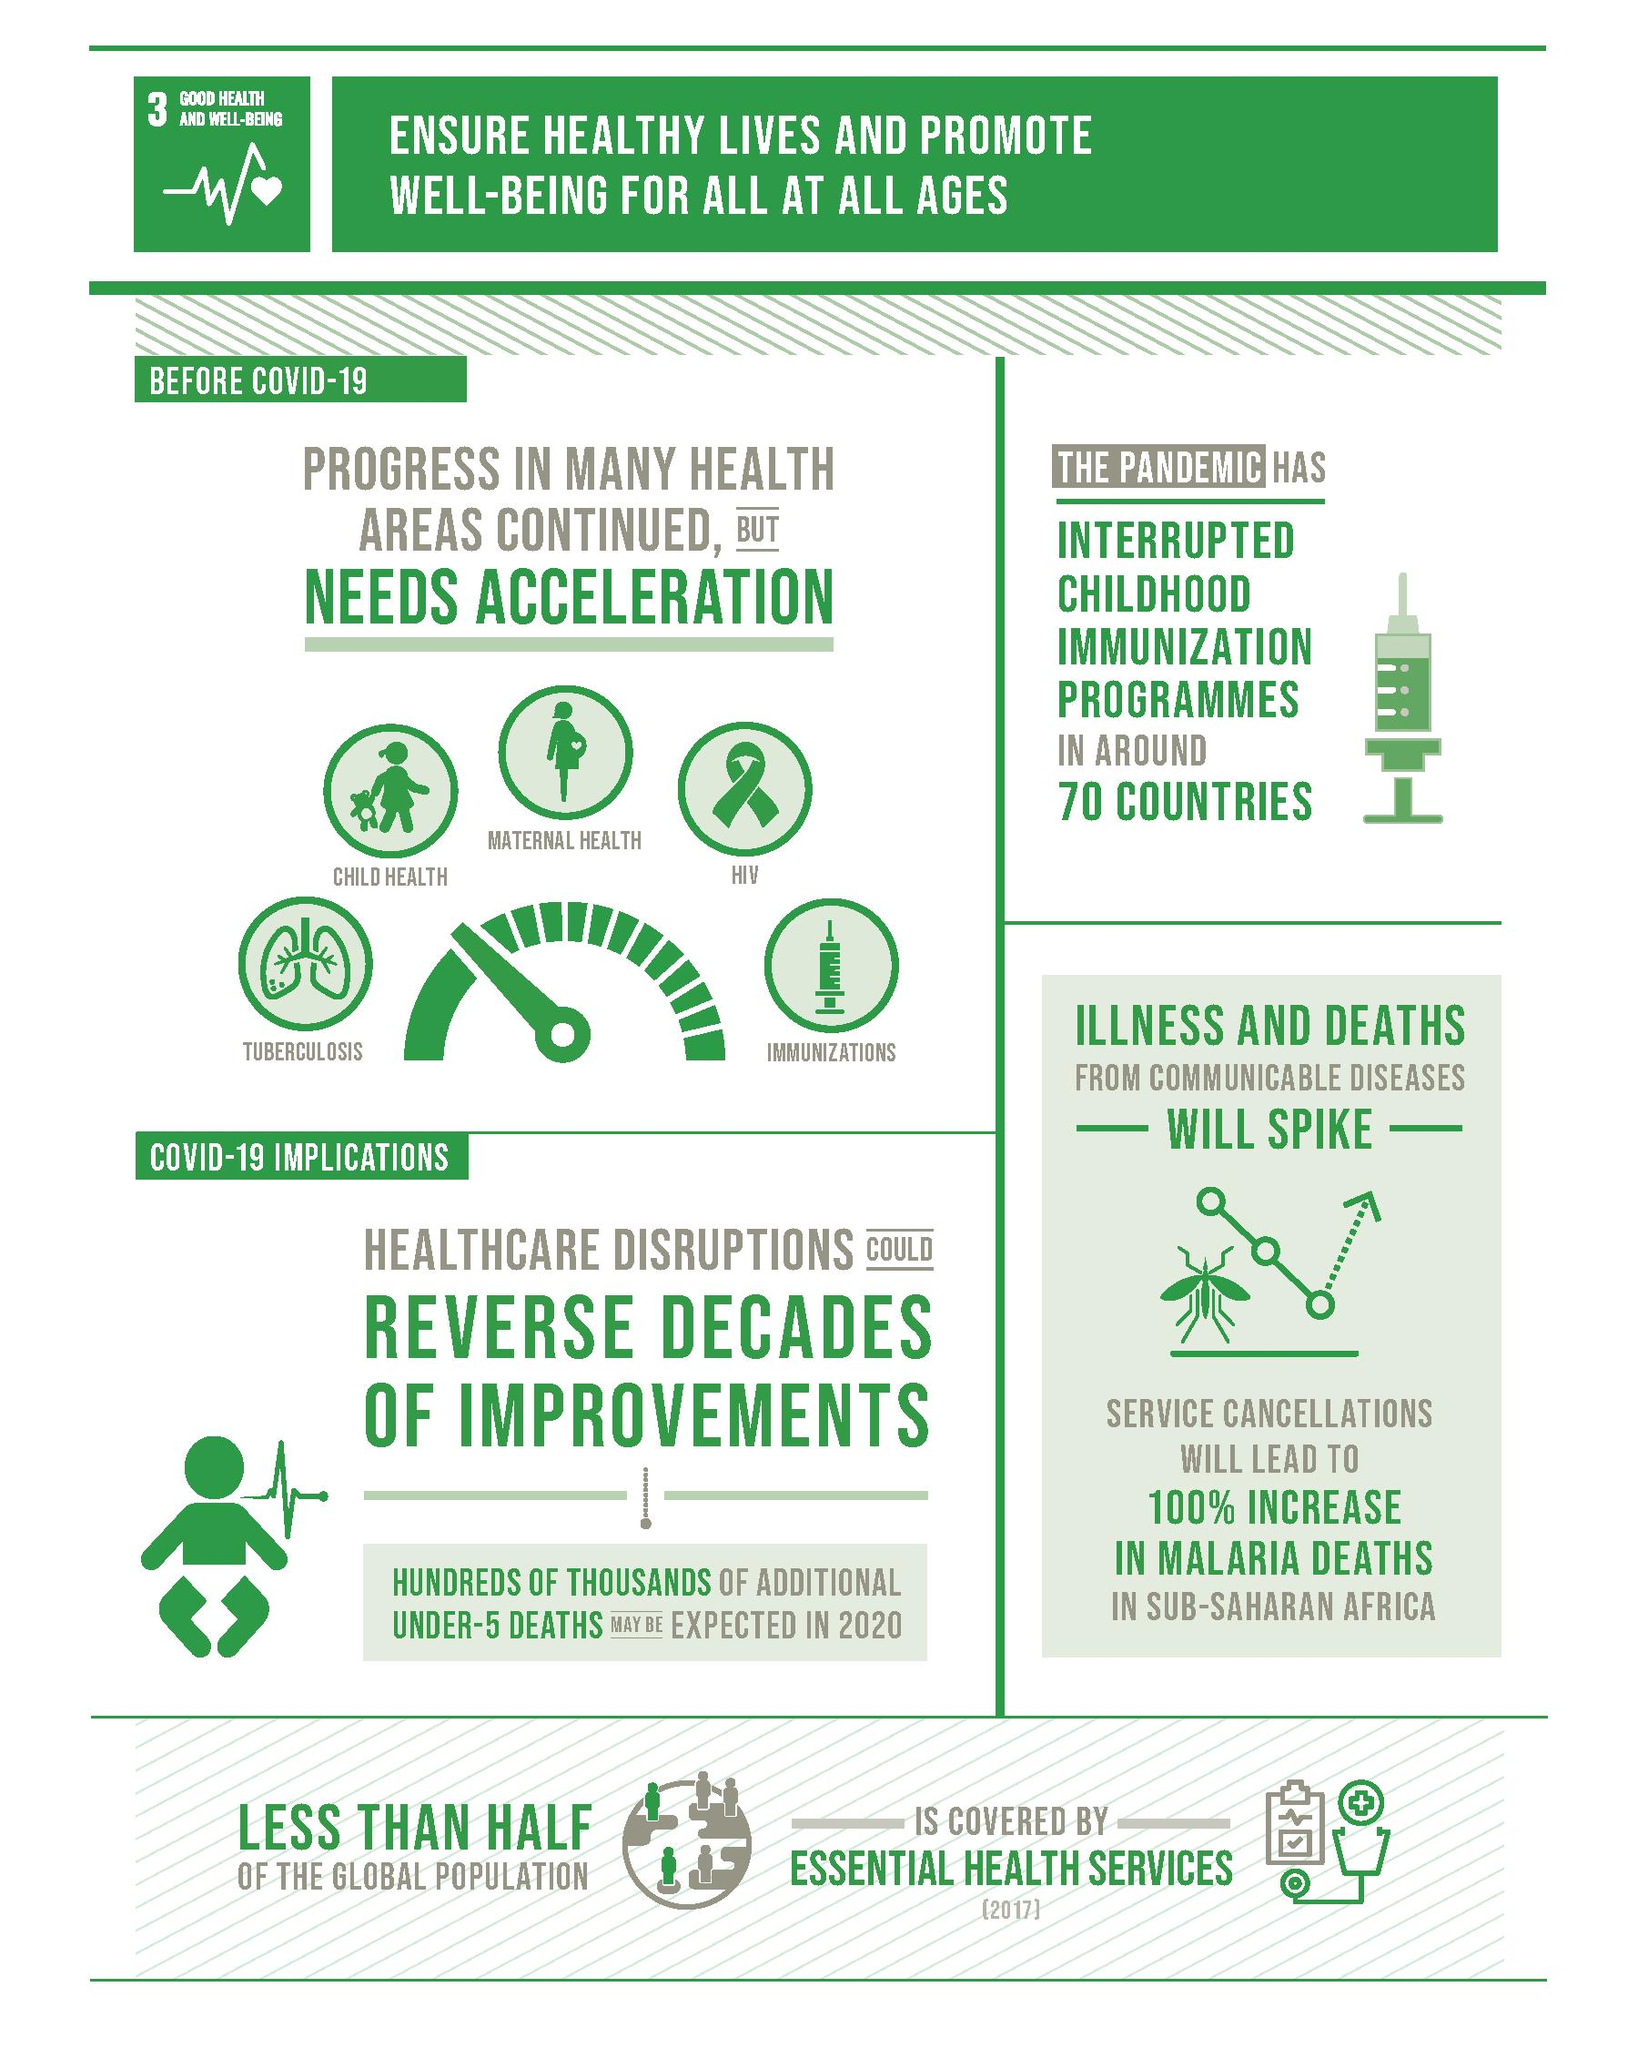Identify some key points in this picture. The image that is commonly used to represent immunization is a syringe. The disease represented by the image of lungs is tuberculosis. Five health areas were necessary for acceleration before the pandemic. The childhood immunization programs in 70 countries were interrupted by the pandemic, resulting in a significant decline in vaccination rates and an increased risk of preventable diseases. In 2020, an estimated hundreds or thousands of additional deaths are expected in the under-5 age group due to the COVID-19 pandemic. 